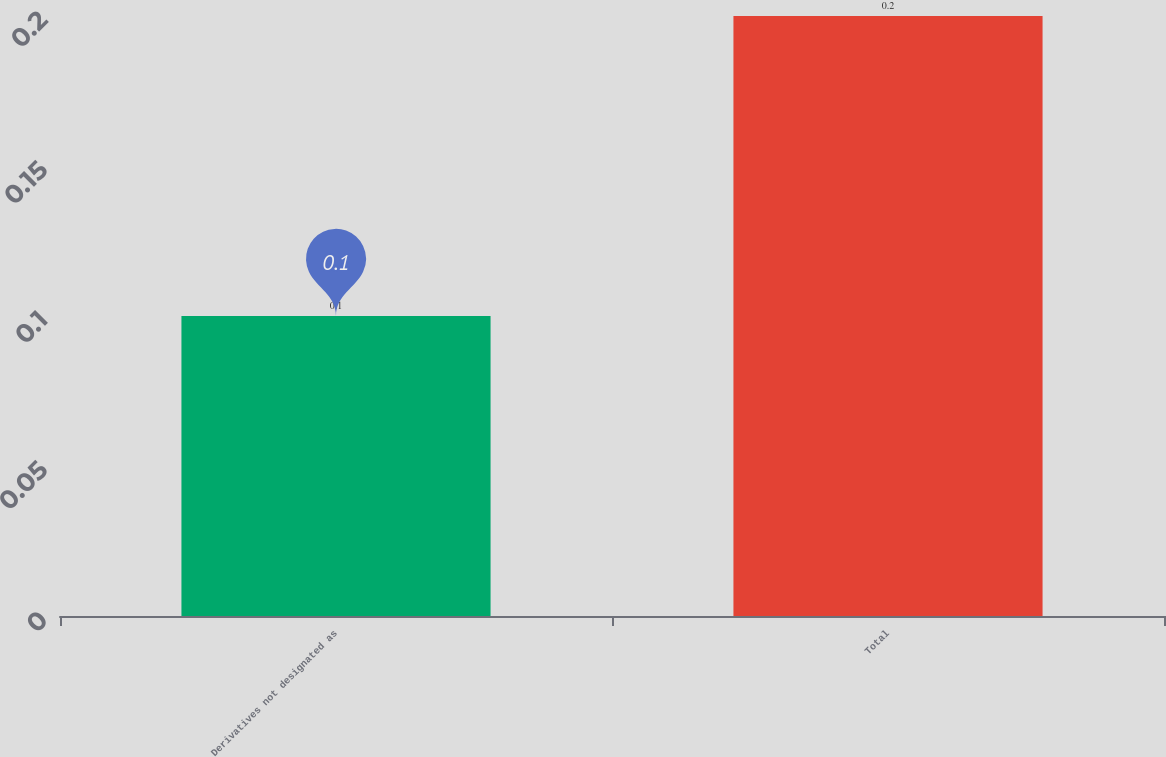<chart> <loc_0><loc_0><loc_500><loc_500><bar_chart><fcel>Derivatives not designated as<fcel>Total<nl><fcel>0.1<fcel>0.2<nl></chart> 